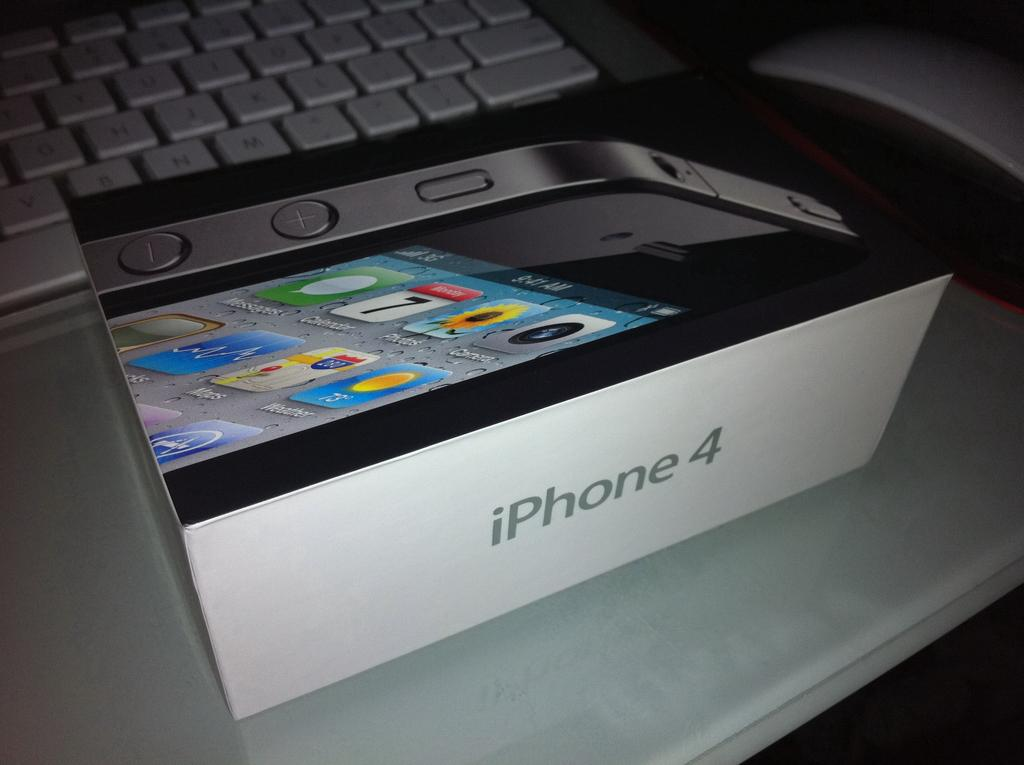Provide a one-sentence caption for the provided image. a box that has the iPhone 4 inside of it. 